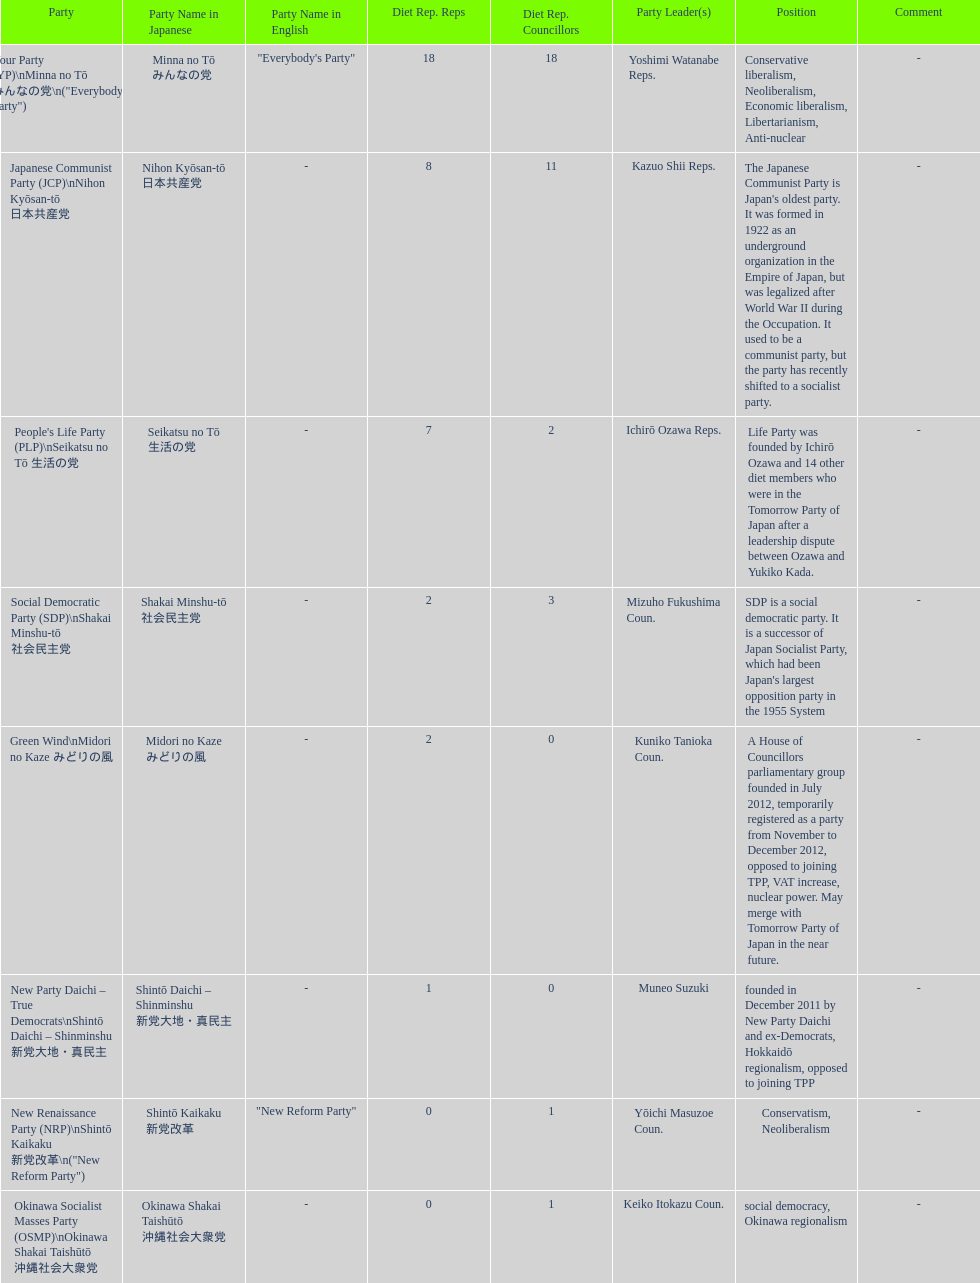People's life party has at most, how many party leaders? 1. Would you be able to parse every entry in this table? {'header': ['Party', 'Party Name in Japanese', 'Party Name in English', 'Diet Rep. Reps', 'Diet Rep. Councillors', 'Party Leader(s)', 'Position', 'Comment'], 'rows': [['Your Party (YP)\\nMinna no Tō みんなの党\\n("Everybody\'s Party")', 'Minna no Tō みんなの党', '"Everybody\'s Party"', '18', '18', 'Yoshimi Watanabe Reps.', 'Conservative liberalism, Neoliberalism, Economic liberalism, Libertarianism, Anti-nuclear', '-'], ['Japanese Communist Party (JCP)\\nNihon Kyōsan-tō 日本共産党', 'Nihon Kyōsan-tō 日本共産党', '-', '8', '11', 'Kazuo Shii Reps.', "The Japanese Communist Party is Japan's oldest party. It was formed in 1922 as an underground organization in the Empire of Japan, but was legalized after World War II during the Occupation. It used to be a communist party, but the party has recently shifted to a socialist party.", '-'], ["People's Life Party (PLP)\\nSeikatsu no Tō 生活の党", 'Seikatsu no Tō 生活の党', '-', '7', '2', 'Ichirō Ozawa Reps.', 'Life Party was founded by Ichirō Ozawa and 14 other diet members who were in the Tomorrow Party of Japan after a leadership dispute between Ozawa and Yukiko Kada.', '-'], ['Social Democratic Party (SDP)\\nShakai Minshu-tō 社会民主党', 'Shakai Minshu-tō 社会民主党', '-', '2', '3', 'Mizuho Fukushima Coun.', "SDP is a social democratic party. It is a successor of Japan Socialist Party, which had been Japan's largest opposition party in the 1955 System", '-'], ['Green Wind\\nMidori no Kaze みどりの風', 'Midori no Kaze みどりの風', '-', '2', '0', 'Kuniko Tanioka Coun.', 'A House of Councillors parliamentary group founded in July 2012, temporarily registered as a party from November to December 2012, opposed to joining TPP, VAT increase, nuclear power. May merge with Tomorrow Party of Japan in the near future.', '-'], ['New Party Daichi – True Democrats\\nShintō Daichi – Shinminshu 新党大地・真民主', 'Shintō Daichi – Shinminshu 新党大地・真民主', '-', '1', '0', 'Muneo Suzuki', 'founded in December 2011 by New Party Daichi and ex-Democrats, Hokkaidō regionalism, opposed to joining TPP', '-'], ['New Renaissance Party (NRP)\\nShintō Kaikaku 新党改革\\n("New Reform Party")', 'Shintō Kaikaku 新党改革', '"New Reform Party"', '0', '1', 'Yōichi Masuzoe Coun.', 'Conservatism, Neoliberalism', '-'], ['Okinawa Socialist Masses Party (OSMP)\\nOkinawa Shakai Taishūtō 沖縄社会大衆党', 'Okinawa Shakai Taishūtō 沖縄社会大衆党', '-', '0', '1', 'Keiko Itokazu Coun.', 'social democracy, Okinawa regionalism', '-']]} 